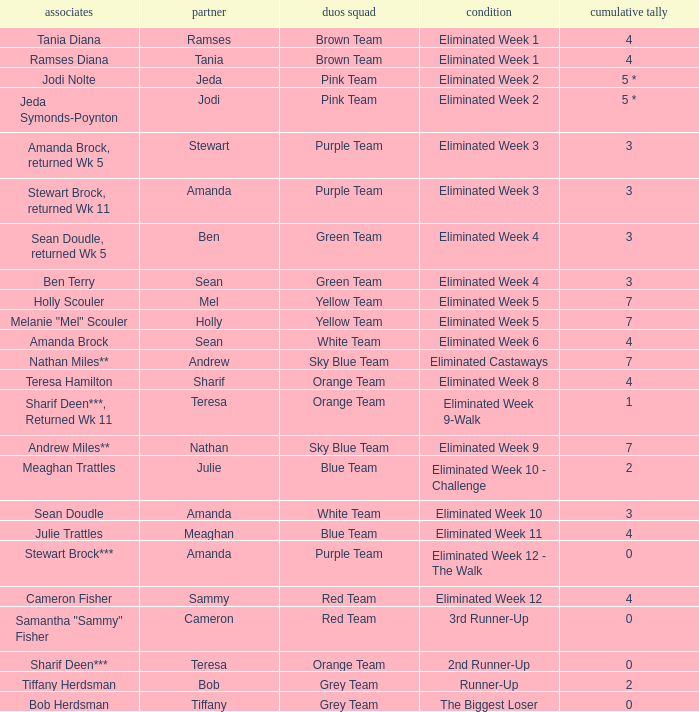What was Holly Scouler's total votes 7.0. 